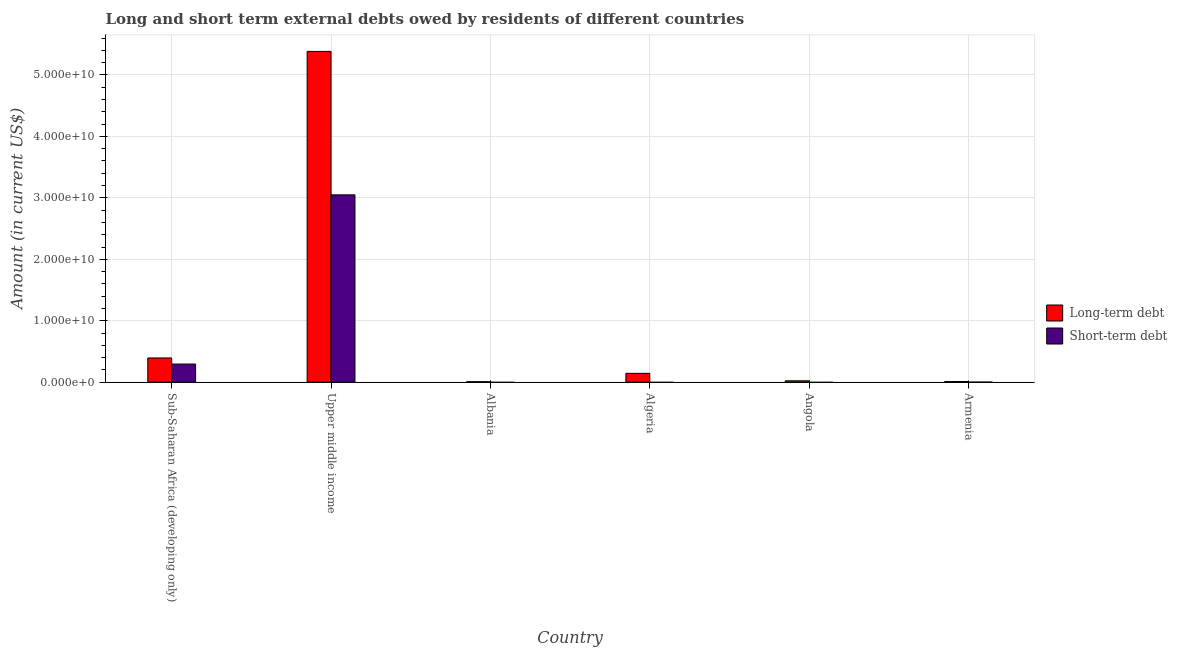Are the number of bars on each tick of the X-axis equal?
Give a very brief answer. No. How many bars are there on the 6th tick from the right?
Offer a terse response. 2. What is the label of the 4th group of bars from the left?
Provide a short and direct response. Algeria. In how many cases, is the number of bars for a given country not equal to the number of legend labels?
Give a very brief answer. 3. What is the long-term debts owed by residents in Armenia?
Offer a very short reply. 9.95e+07. Across all countries, what is the maximum long-term debts owed by residents?
Your response must be concise. 5.38e+1. Across all countries, what is the minimum short-term debts owed by residents?
Give a very brief answer. 0. In which country was the short-term debts owed by residents maximum?
Provide a short and direct response. Upper middle income. What is the total short-term debts owed by residents in the graph?
Ensure brevity in your answer.  3.34e+1. What is the difference between the long-term debts owed by residents in Albania and that in Sub-Saharan Africa (developing only)?
Your answer should be very brief. -3.86e+09. What is the difference between the short-term debts owed by residents in Upper middle income and the long-term debts owed by residents in Armenia?
Your response must be concise. 3.04e+1. What is the average long-term debts owed by residents per country?
Provide a succinct answer. 9.93e+09. What is the difference between the short-term debts owed by residents and long-term debts owed by residents in Armenia?
Make the answer very short. -9.85e+07. What is the ratio of the short-term debts owed by residents in Armenia to that in Sub-Saharan Africa (developing only)?
Keep it short and to the point. 0. Is the long-term debts owed by residents in Albania less than that in Armenia?
Provide a succinct answer. Yes. What is the difference between the highest and the second highest long-term debts owed by residents?
Your response must be concise. 4.99e+1. What is the difference between the highest and the lowest long-term debts owed by residents?
Offer a terse response. 5.38e+1. Is the sum of the long-term debts owed by residents in Angola and Armenia greater than the maximum short-term debts owed by residents across all countries?
Provide a succinct answer. No. How many bars are there?
Ensure brevity in your answer.  9. Are the values on the major ticks of Y-axis written in scientific E-notation?
Your answer should be compact. Yes. Does the graph contain any zero values?
Provide a succinct answer. Yes. Does the graph contain grids?
Your answer should be compact. Yes. How many legend labels are there?
Your answer should be very brief. 2. What is the title of the graph?
Give a very brief answer. Long and short term external debts owed by residents of different countries. What is the label or title of the X-axis?
Your answer should be very brief. Country. What is the Amount (in current US$) of Long-term debt in Sub-Saharan Africa (developing only)?
Your response must be concise. 3.94e+09. What is the Amount (in current US$) in Short-term debt in Sub-Saharan Africa (developing only)?
Your answer should be very brief. 2.95e+09. What is the Amount (in current US$) in Long-term debt in Upper middle income?
Your answer should be very brief. 5.38e+1. What is the Amount (in current US$) in Short-term debt in Upper middle income?
Provide a succinct answer. 3.05e+1. What is the Amount (in current US$) of Long-term debt in Albania?
Your response must be concise. 7.18e+07. What is the Amount (in current US$) in Short-term debt in Albania?
Keep it short and to the point. 0. What is the Amount (in current US$) in Long-term debt in Algeria?
Provide a succinct answer. 1.43e+09. What is the Amount (in current US$) in Short-term debt in Algeria?
Ensure brevity in your answer.  0. What is the Amount (in current US$) of Long-term debt in Angola?
Give a very brief answer. 2.18e+08. What is the Amount (in current US$) of Short-term debt in Angola?
Offer a very short reply. 0. What is the Amount (in current US$) of Long-term debt in Armenia?
Offer a terse response. 9.95e+07. What is the Amount (in current US$) of Short-term debt in Armenia?
Offer a terse response. 1.00e+06. Across all countries, what is the maximum Amount (in current US$) of Long-term debt?
Provide a short and direct response. 5.38e+1. Across all countries, what is the maximum Amount (in current US$) of Short-term debt?
Your response must be concise. 3.05e+1. Across all countries, what is the minimum Amount (in current US$) in Long-term debt?
Give a very brief answer. 7.18e+07. What is the total Amount (in current US$) in Long-term debt in the graph?
Provide a succinct answer. 5.96e+1. What is the total Amount (in current US$) of Short-term debt in the graph?
Give a very brief answer. 3.34e+1. What is the difference between the Amount (in current US$) in Long-term debt in Sub-Saharan Africa (developing only) and that in Upper middle income?
Provide a short and direct response. -4.99e+1. What is the difference between the Amount (in current US$) of Short-term debt in Sub-Saharan Africa (developing only) and that in Upper middle income?
Your answer should be very brief. -2.75e+1. What is the difference between the Amount (in current US$) of Long-term debt in Sub-Saharan Africa (developing only) and that in Albania?
Offer a very short reply. 3.86e+09. What is the difference between the Amount (in current US$) of Long-term debt in Sub-Saharan Africa (developing only) and that in Algeria?
Provide a succinct answer. 2.50e+09. What is the difference between the Amount (in current US$) in Long-term debt in Sub-Saharan Africa (developing only) and that in Angola?
Your answer should be compact. 3.72e+09. What is the difference between the Amount (in current US$) of Long-term debt in Sub-Saharan Africa (developing only) and that in Armenia?
Provide a short and direct response. 3.84e+09. What is the difference between the Amount (in current US$) in Short-term debt in Sub-Saharan Africa (developing only) and that in Armenia?
Give a very brief answer. 2.95e+09. What is the difference between the Amount (in current US$) in Long-term debt in Upper middle income and that in Albania?
Your answer should be very brief. 5.38e+1. What is the difference between the Amount (in current US$) of Long-term debt in Upper middle income and that in Algeria?
Offer a terse response. 5.24e+1. What is the difference between the Amount (in current US$) in Long-term debt in Upper middle income and that in Angola?
Your response must be concise. 5.36e+1. What is the difference between the Amount (in current US$) in Long-term debt in Upper middle income and that in Armenia?
Provide a short and direct response. 5.37e+1. What is the difference between the Amount (in current US$) of Short-term debt in Upper middle income and that in Armenia?
Offer a terse response. 3.05e+1. What is the difference between the Amount (in current US$) of Long-term debt in Albania and that in Algeria?
Your response must be concise. -1.36e+09. What is the difference between the Amount (in current US$) in Long-term debt in Albania and that in Angola?
Make the answer very short. -1.46e+08. What is the difference between the Amount (in current US$) in Long-term debt in Albania and that in Armenia?
Give a very brief answer. -2.78e+07. What is the difference between the Amount (in current US$) of Long-term debt in Algeria and that in Angola?
Offer a terse response. 1.22e+09. What is the difference between the Amount (in current US$) in Long-term debt in Algeria and that in Armenia?
Your answer should be compact. 1.34e+09. What is the difference between the Amount (in current US$) in Long-term debt in Angola and that in Armenia?
Provide a short and direct response. 1.19e+08. What is the difference between the Amount (in current US$) in Long-term debt in Sub-Saharan Africa (developing only) and the Amount (in current US$) in Short-term debt in Upper middle income?
Offer a terse response. -2.66e+1. What is the difference between the Amount (in current US$) in Long-term debt in Sub-Saharan Africa (developing only) and the Amount (in current US$) in Short-term debt in Armenia?
Give a very brief answer. 3.94e+09. What is the difference between the Amount (in current US$) in Long-term debt in Upper middle income and the Amount (in current US$) in Short-term debt in Armenia?
Provide a succinct answer. 5.38e+1. What is the difference between the Amount (in current US$) in Long-term debt in Albania and the Amount (in current US$) in Short-term debt in Armenia?
Your answer should be very brief. 7.08e+07. What is the difference between the Amount (in current US$) in Long-term debt in Algeria and the Amount (in current US$) in Short-term debt in Armenia?
Keep it short and to the point. 1.43e+09. What is the difference between the Amount (in current US$) of Long-term debt in Angola and the Amount (in current US$) of Short-term debt in Armenia?
Provide a short and direct response. 2.17e+08. What is the average Amount (in current US$) of Long-term debt per country?
Give a very brief answer. 9.93e+09. What is the average Amount (in current US$) in Short-term debt per country?
Your answer should be compact. 5.57e+09. What is the difference between the Amount (in current US$) of Long-term debt and Amount (in current US$) of Short-term debt in Sub-Saharan Africa (developing only)?
Provide a short and direct response. 9.89e+08. What is the difference between the Amount (in current US$) in Long-term debt and Amount (in current US$) in Short-term debt in Upper middle income?
Keep it short and to the point. 2.34e+1. What is the difference between the Amount (in current US$) of Long-term debt and Amount (in current US$) of Short-term debt in Armenia?
Your answer should be very brief. 9.85e+07. What is the ratio of the Amount (in current US$) of Long-term debt in Sub-Saharan Africa (developing only) to that in Upper middle income?
Keep it short and to the point. 0.07. What is the ratio of the Amount (in current US$) in Short-term debt in Sub-Saharan Africa (developing only) to that in Upper middle income?
Your response must be concise. 0.1. What is the ratio of the Amount (in current US$) in Long-term debt in Sub-Saharan Africa (developing only) to that in Albania?
Keep it short and to the point. 54.84. What is the ratio of the Amount (in current US$) of Long-term debt in Sub-Saharan Africa (developing only) to that in Algeria?
Keep it short and to the point. 2.74. What is the ratio of the Amount (in current US$) of Long-term debt in Sub-Saharan Africa (developing only) to that in Angola?
Your answer should be compact. 18.04. What is the ratio of the Amount (in current US$) in Long-term debt in Sub-Saharan Africa (developing only) to that in Armenia?
Offer a very short reply. 39.54. What is the ratio of the Amount (in current US$) in Short-term debt in Sub-Saharan Africa (developing only) to that in Armenia?
Provide a succinct answer. 2946.78. What is the ratio of the Amount (in current US$) of Long-term debt in Upper middle income to that in Albania?
Provide a succinct answer. 750.09. What is the ratio of the Amount (in current US$) in Long-term debt in Upper middle income to that in Algeria?
Your answer should be very brief. 37.53. What is the ratio of the Amount (in current US$) in Long-term debt in Upper middle income to that in Angola?
Keep it short and to the point. 246.81. What is the ratio of the Amount (in current US$) in Long-term debt in Upper middle income to that in Armenia?
Provide a short and direct response. 540.83. What is the ratio of the Amount (in current US$) in Short-term debt in Upper middle income to that in Armenia?
Your answer should be very brief. 3.05e+04. What is the ratio of the Amount (in current US$) in Long-term debt in Albania to that in Angola?
Give a very brief answer. 0.33. What is the ratio of the Amount (in current US$) of Long-term debt in Albania to that in Armenia?
Make the answer very short. 0.72. What is the ratio of the Amount (in current US$) in Long-term debt in Algeria to that in Angola?
Provide a short and direct response. 6.58. What is the ratio of the Amount (in current US$) in Long-term debt in Algeria to that in Armenia?
Your answer should be compact. 14.41. What is the ratio of the Amount (in current US$) in Long-term debt in Angola to that in Armenia?
Give a very brief answer. 2.19. What is the difference between the highest and the second highest Amount (in current US$) of Long-term debt?
Give a very brief answer. 4.99e+1. What is the difference between the highest and the second highest Amount (in current US$) of Short-term debt?
Your answer should be compact. 2.75e+1. What is the difference between the highest and the lowest Amount (in current US$) in Long-term debt?
Your response must be concise. 5.38e+1. What is the difference between the highest and the lowest Amount (in current US$) of Short-term debt?
Your answer should be compact. 3.05e+1. 